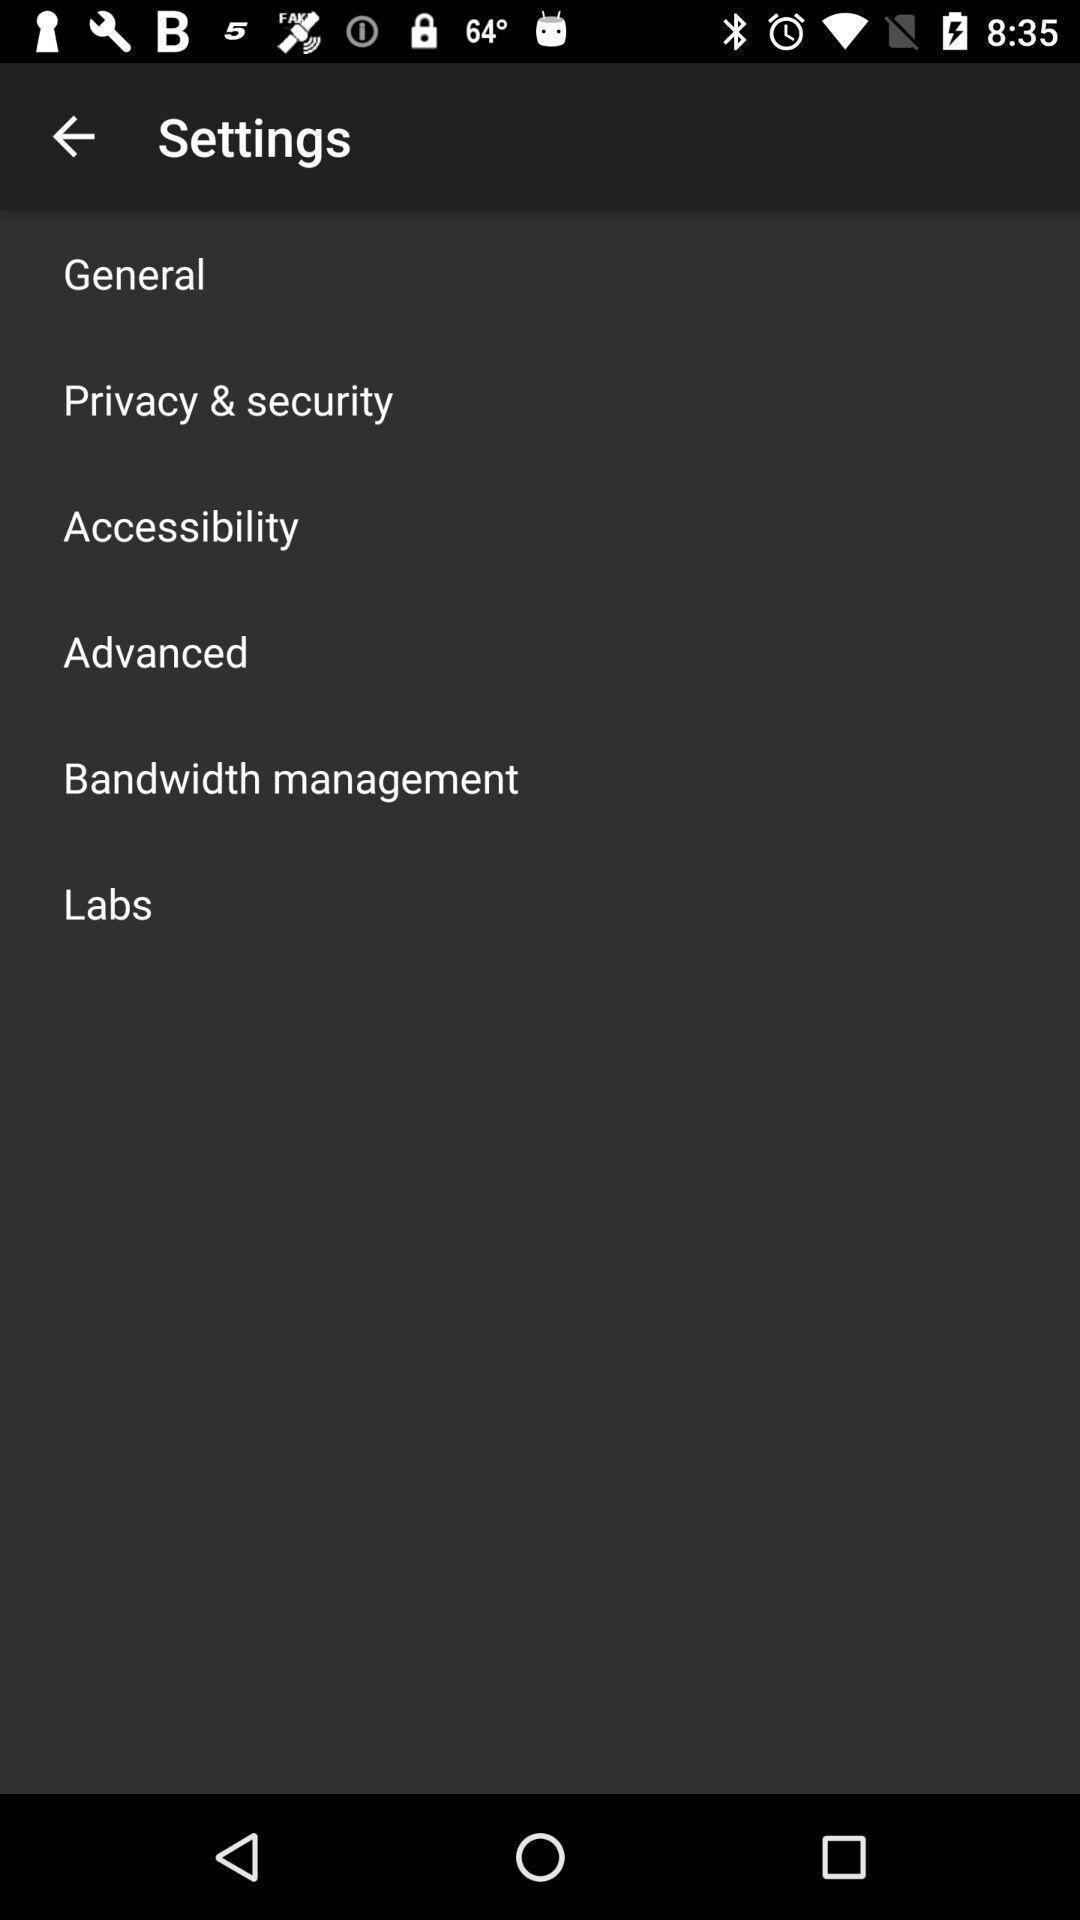Summarize the information in this screenshot. Screen showing settings page. 